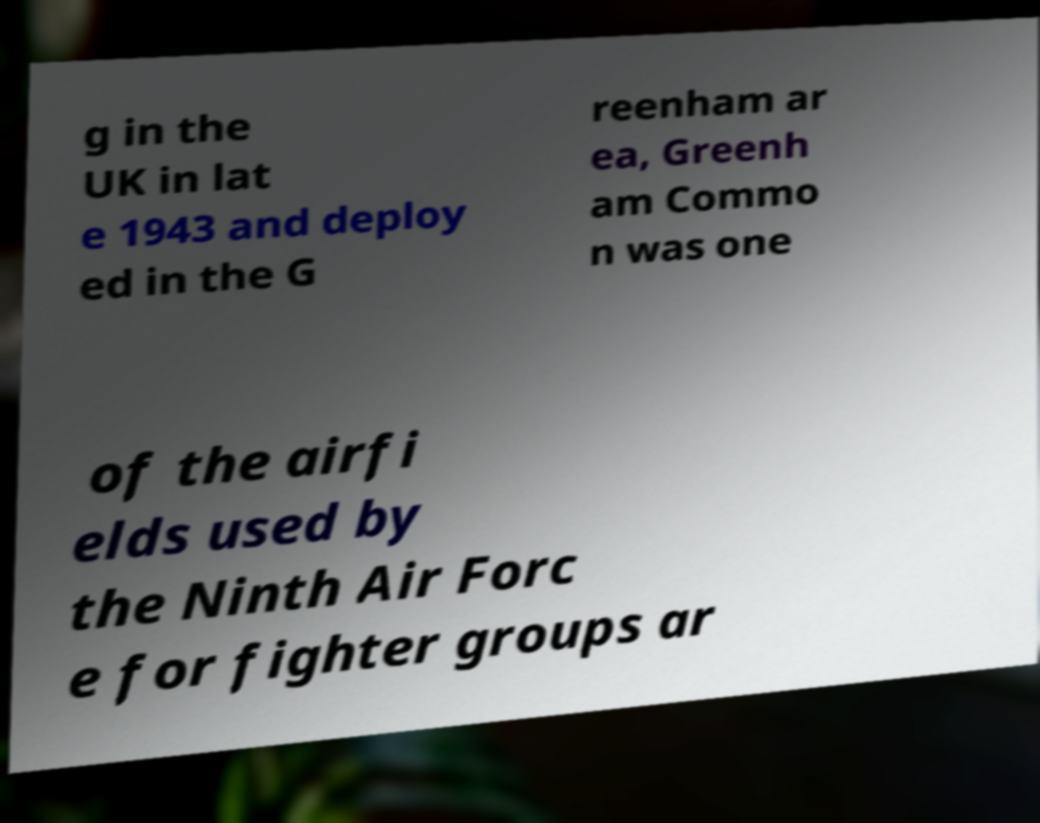Could you assist in decoding the text presented in this image and type it out clearly? g in the UK in lat e 1943 and deploy ed in the G reenham ar ea, Greenh am Commo n was one of the airfi elds used by the Ninth Air Forc e for fighter groups ar 